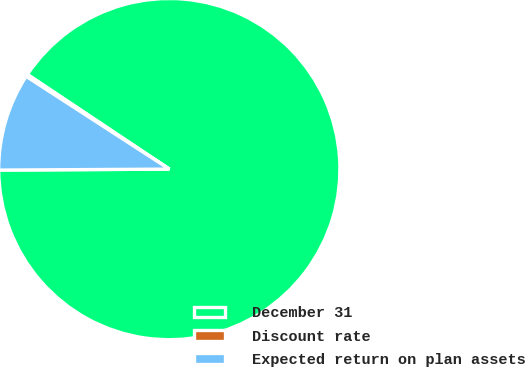Convert chart. <chart><loc_0><loc_0><loc_500><loc_500><pie_chart><fcel>December 31<fcel>Discount rate<fcel>Expected return on plan assets<nl><fcel>90.54%<fcel>0.21%<fcel>9.24%<nl></chart> 